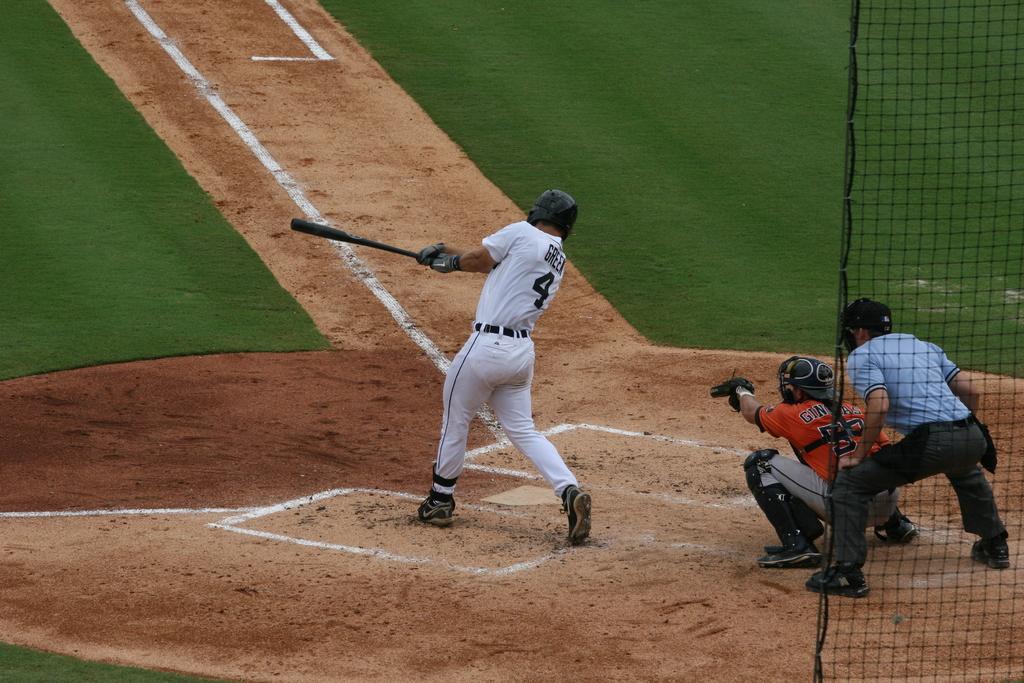Please provide a concise description of this image. In this image we can see there is a person playing with a baseball bat in the playground, behind this person there is another person sitting, behind this person there is another person standing and there is a net fence. 